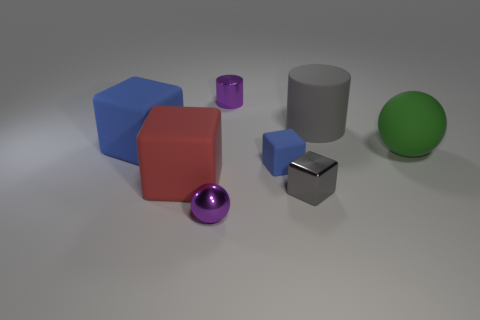Do the big matte thing that is in front of the small blue rubber block and the gray rubber object have the same shape? No, they do not have the same shape. The larger object is a matte-finished cube, while the small object in question appears to be a metallic cube with a reflective surface, which is distinct from the matte texture of the larger cube. 